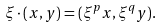Convert formula to latex. <formula><loc_0><loc_0><loc_500><loc_500>\xi \cdot ( x , y ) = ( \xi ^ { p } x , \xi ^ { q } y ) .</formula> 